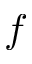Convert formula to latex. <formula><loc_0><loc_0><loc_500><loc_500>f</formula> 